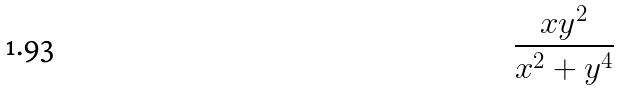Convert formula to latex. <formula><loc_0><loc_0><loc_500><loc_500>\frac { x y ^ { 2 } } { x ^ { 2 } + y ^ { 4 } }</formula> 